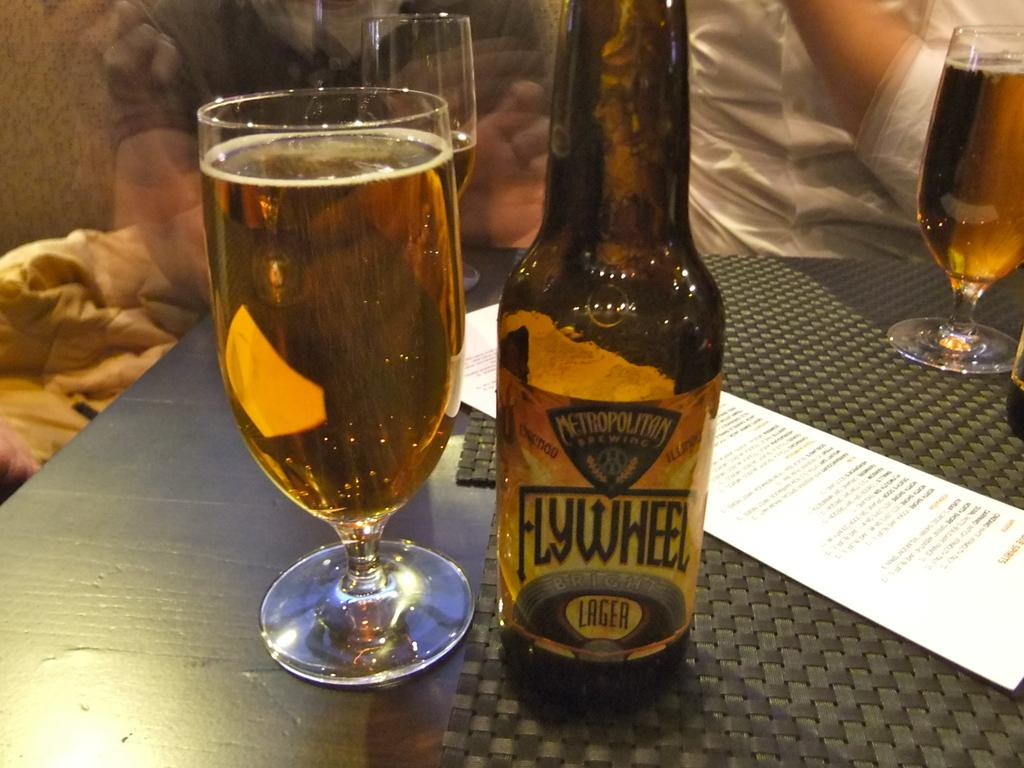<image>
Create a compact narrative representing the image presented. A bottle of lager with the title Metropolitan Flywheel written on it, sitting next to a full glass of beer. 